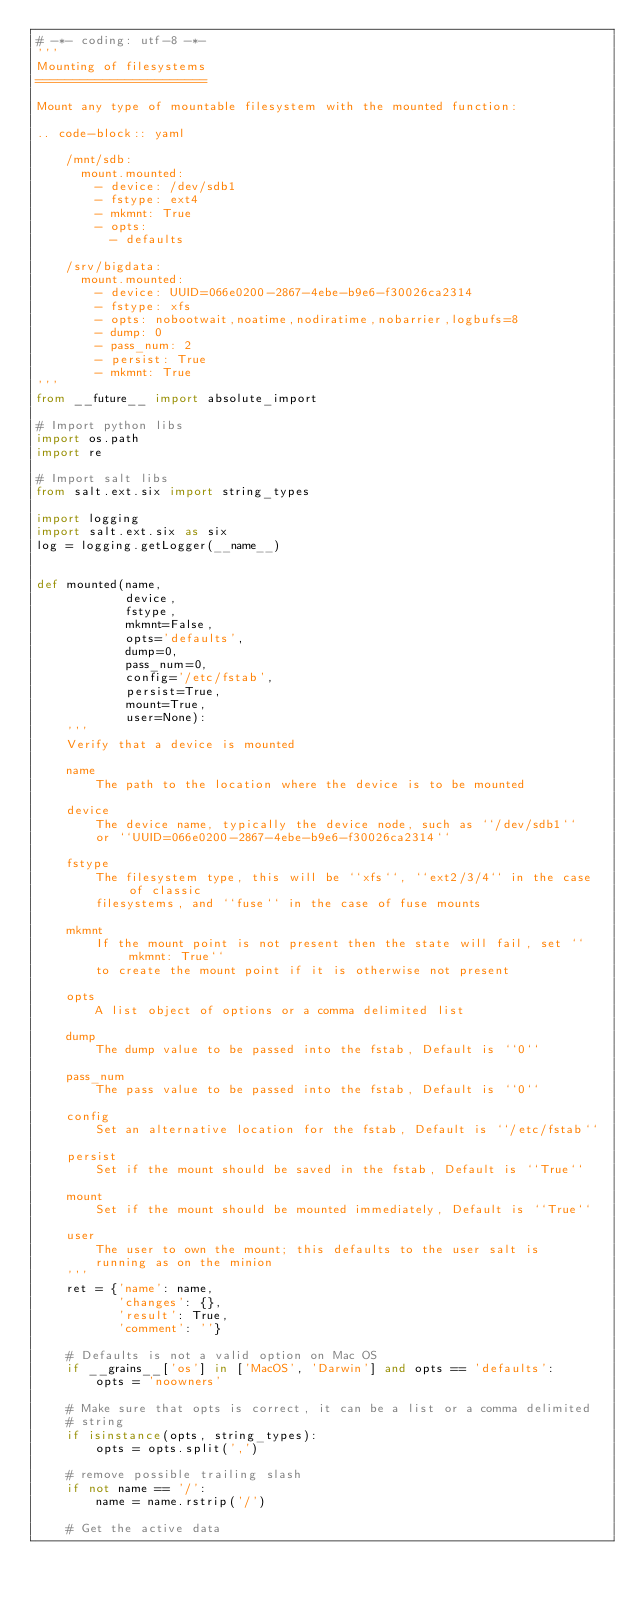Convert code to text. <code><loc_0><loc_0><loc_500><loc_500><_Python_># -*- coding: utf-8 -*-
'''
Mounting of filesystems
=======================

Mount any type of mountable filesystem with the mounted function:

.. code-block:: yaml

    /mnt/sdb:
      mount.mounted:
        - device: /dev/sdb1
        - fstype: ext4
        - mkmnt: True
        - opts:
          - defaults

    /srv/bigdata:
      mount.mounted:
        - device: UUID=066e0200-2867-4ebe-b9e6-f30026ca2314
        - fstype: xfs
        - opts: nobootwait,noatime,nodiratime,nobarrier,logbufs=8
        - dump: 0
        - pass_num: 2
        - persist: True
        - mkmnt: True
'''
from __future__ import absolute_import

# Import python libs
import os.path
import re

# Import salt libs
from salt.ext.six import string_types

import logging
import salt.ext.six as six
log = logging.getLogger(__name__)


def mounted(name,
            device,
            fstype,
            mkmnt=False,
            opts='defaults',
            dump=0,
            pass_num=0,
            config='/etc/fstab',
            persist=True,
            mount=True,
            user=None):
    '''
    Verify that a device is mounted

    name
        The path to the location where the device is to be mounted

    device
        The device name, typically the device node, such as ``/dev/sdb1``
        or ``UUID=066e0200-2867-4ebe-b9e6-f30026ca2314``

    fstype
        The filesystem type, this will be ``xfs``, ``ext2/3/4`` in the case of classic
        filesystems, and ``fuse`` in the case of fuse mounts

    mkmnt
        If the mount point is not present then the state will fail, set ``mkmnt: True``
        to create the mount point if it is otherwise not present

    opts
        A list object of options or a comma delimited list

    dump
        The dump value to be passed into the fstab, Default is ``0``

    pass_num
        The pass value to be passed into the fstab, Default is ``0``

    config
        Set an alternative location for the fstab, Default is ``/etc/fstab``

    persist
        Set if the mount should be saved in the fstab, Default is ``True``

    mount
        Set if the mount should be mounted immediately, Default is ``True``

    user
        The user to own the mount; this defaults to the user salt is
        running as on the minion
    '''
    ret = {'name': name,
           'changes': {},
           'result': True,
           'comment': ''}

    # Defaults is not a valid option on Mac OS
    if __grains__['os'] in ['MacOS', 'Darwin'] and opts == 'defaults':
        opts = 'noowners'

    # Make sure that opts is correct, it can be a list or a comma delimited
    # string
    if isinstance(opts, string_types):
        opts = opts.split(',')

    # remove possible trailing slash
    if not name == '/':
        name = name.rstrip('/')

    # Get the active data</code> 